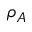Convert formula to latex. <formula><loc_0><loc_0><loc_500><loc_500>\rho _ { A }</formula> 